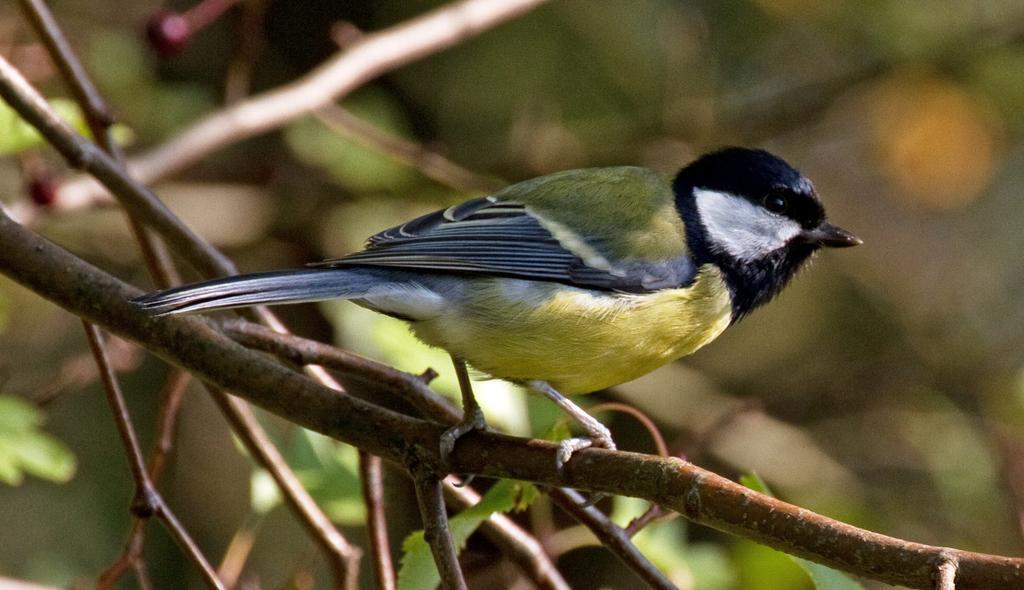In one or two sentences, can you explain what this image depicts? In this image, we can see a bird is standing on the tree stem. Here we can see few leaves. Background there is a blur view. 